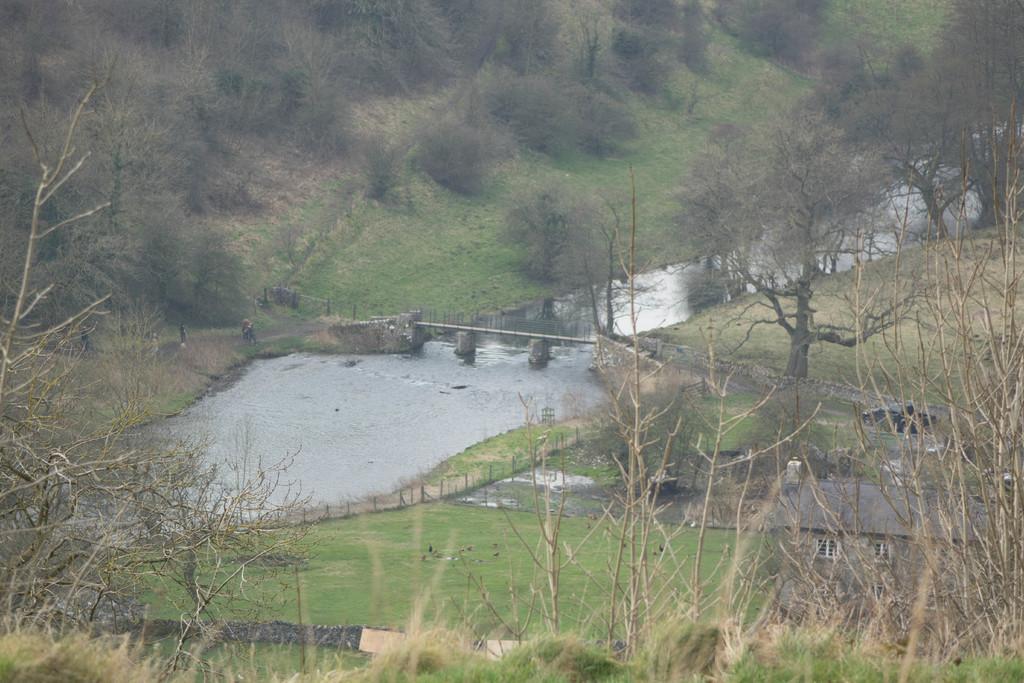Describe this image in one or two sentences. In this image we can see a bridge, there are some trees, water, grass, poles, houses and plants. 